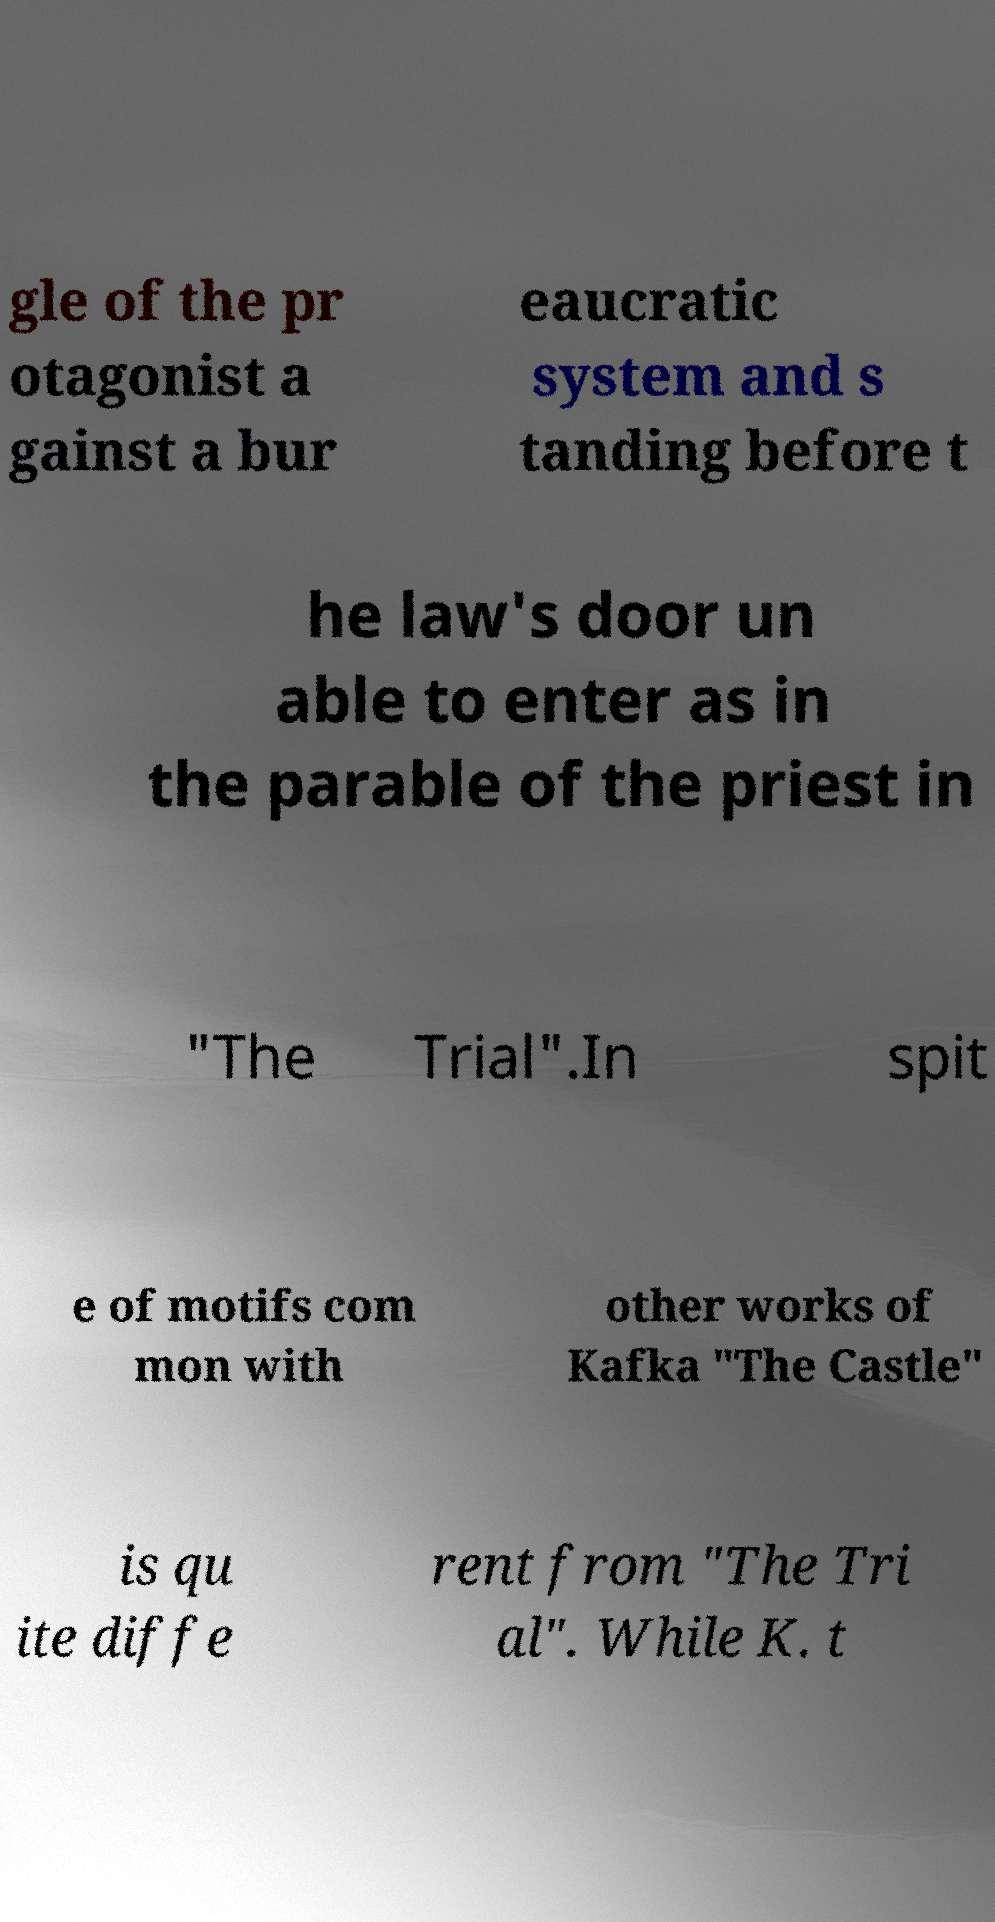Could you assist in decoding the text presented in this image and type it out clearly? gle of the pr otagonist a gainst a bur eaucratic system and s tanding before t he law's door un able to enter as in the parable of the priest in "The Trial".In spit e of motifs com mon with other works of Kafka "The Castle" is qu ite diffe rent from "The Tri al". While K. t 